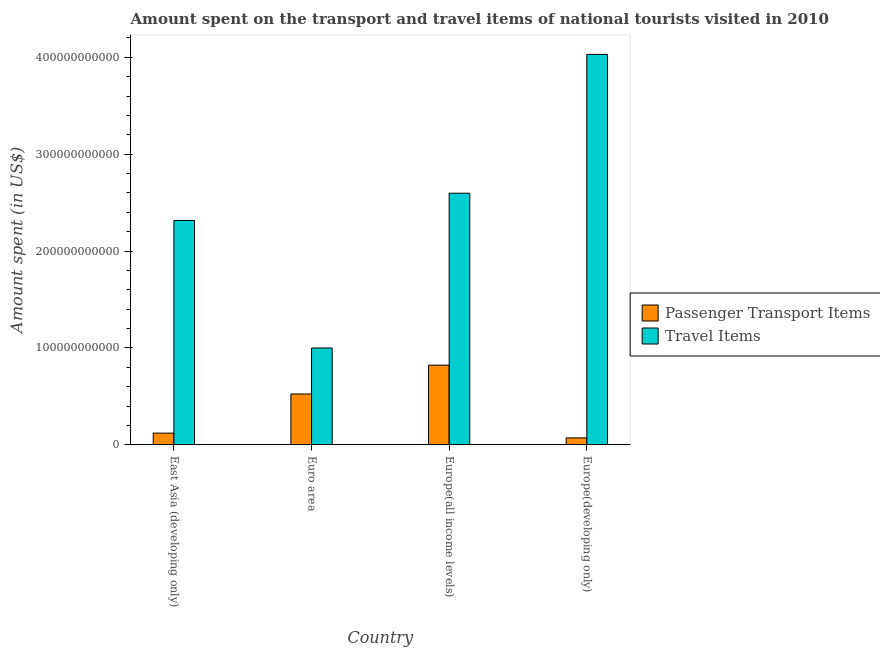How many groups of bars are there?
Make the answer very short. 4. How many bars are there on the 2nd tick from the left?
Ensure brevity in your answer.  2. How many bars are there on the 1st tick from the right?
Make the answer very short. 2. What is the label of the 3rd group of bars from the left?
Your response must be concise. Europe(all income levels). What is the amount spent on passenger transport items in Europe(developing only)?
Give a very brief answer. 7.14e+09. Across all countries, what is the maximum amount spent on passenger transport items?
Ensure brevity in your answer.  8.22e+1. Across all countries, what is the minimum amount spent in travel items?
Give a very brief answer. 9.99e+1. In which country was the amount spent in travel items maximum?
Give a very brief answer. Europe(developing only). In which country was the amount spent on passenger transport items minimum?
Provide a succinct answer. Europe(developing only). What is the total amount spent in travel items in the graph?
Your response must be concise. 9.94e+11. What is the difference between the amount spent in travel items in Europe(all income levels) and that in Europe(developing only)?
Provide a succinct answer. -1.43e+11. What is the difference between the amount spent in travel items in Euro area and the amount spent on passenger transport items in Europe(all income levels)?
Offer a very short reply. 1.77e+1. What is the average amount spent on passenger transport items per country?
Offer a very short reply. 3.85e+1. What is the difference between the amount spent on passenger transport items and amount spent in travel items in East Asia (developing only)?
Keep it short and to the point. -2.20e+11. What is the ratio of the amount spent in travel items in Europe(all income levels) to that in Europe(developing only)?
Your answer should be very brief. 0.64. Is the difference between the amount spent on passenger transport items in East Asia (developing only) and Europe(developing only) greater than the difference between the amount spent in travel items in East Asia (developing only) and Europe(developing only)?
Your response must be concise. Yes. What is the difference between the highest and the second highest amount spent in travel items?
Offer a very short reply. 1.43e+11. What is the difference between the highest and the lowest amount spent in travel items?
Make the answer very short. 3.03e+11. What does the 1st bar from the left in Europe(all income levels) represents?
Provide a short and direct response. Passenger Transport Items. What does the 1st bar from the right in Europe(developing only) represents?
Ensure brevity in your answer.  Travel Items. How many bars are there?
Offer a very short reply. 8. Are all the bars in the graph horizontal?
Keep it short and to the point. No. How many countries are there in the graph?
Your answer should be very brief. 4. What is the difference between two consecutive major ticks on the Y-axis?
Offer a terse response. 1.00e+11. Are the values on the major ticks of Y-axis written in scientific E-notation?
Ensure brevity in your answer.  No. Does the graph contain any zero values?
Give a very brief answer. No. How many legend labels are there?
Provide a succinct answer. 2. How are the legend labels stacked?
Offer a very short reply. Vertical. What is the title of the graph?
Ensure brevity in your answer.  Amount spent on the transport and travel items of national tourists visited in 2010. What is the label or title of the Y-axis?
Your response must be concise. Amount spent (in US$). What is the Amount spent (in US$) of Passenger Transport Items in East Asia (developing only)?
Keep it short and to the point. 1.20e+1. What is the Amount spent (in US$) of Travel Items in East Asia (developing only)?
Your response must be concise. 2.32e+11. What is the Amount spent (in US$) in Passenger Transport Items in Euro area?
Your answer should be compact. 5.25e+1. What is the Amount spent (in US$) in Travel Items in Euro area?
Your answer should be very brief. 9.99e+1. What is the Amount spent (in US$) in Passenger Transport Items in Europe(all income levels)?
Your response must be concise. 8.22e+1. What is the Amount spent (in US$) of Travel Items in Europe(all income levels)?
Provide a short and direct response. 2.60e+11. What is the Amount spent (in US$) in Passenger Transport Items in Europe(developing only)?
Ensure brevity in your answer.  7.14e+09. What is the Amount spent (in US$) of Travel Items in Europe(developing only)?
Offer a very short reply. 4.03e+11. Across all countries, what is the maximum Amount spent (in US$) in Passenger Transport Items?
Offer a terse response. 8.22e+1. Across all countries, what is the maximum Amount spent (in US$) in Travel Items?
Make the answer very short. 4.03e+11. Across all countries, what is the minimum Amount spent (in US$) of Passenger Transport Items?
Offer a very short reply. 7.14e+09. Across all countries, what is the minimum Amount spent (in US$) in Travel Items?
Keep it short and to the point. 9.99e+1. What is the total Amount spent (in US$) in Passenger Transport Items in the graph?
Your answer should be very brief. 1.54e+11. What is the total Amount spent (in US$) of Travel Items in the graph?
Your response must be concise. 9.94e+11. What is the difference between the Amount spent (in US$) in Passenger Transport Items in East Asia (developing only) and that in Euro area?
Keep it short and to the point. -4.04e+1. What is the difference between the Amount spent (in US$) of Travel Items in East Asia (developing only) and that in Euro area?
Offer a very short reply. 1.32e+11. What is the difference between the Amount spent (in US$) of Passenger Transport Items in East Asia (developing only) and that in Europe(all income levels)?
Provide a short and direct response. -7.02e+1. What is the difference between the Amount spent (in US$) of Travel Items in East Asia (developing only) and that in Europe(all income levels)?
Ensure brevity in your answer.  -2.81e+1. What is the difference between the Amount spent (in US$) in Passenger Transport Items in East Asia (developing only) and that in Europe(developing only)?
Give a very brief answer. 4.90e+09. What is the difference between the Amount spent (in US$) in Travel Items in East Asia (developing only) and that in Europe(developing only)?
Your answer should be very brief. -1.71e+11. What is the difference between the Amount spent (in US$) of Passenger Transport Items in Euro area and that in Europe(all income levels)?
Your answer should be very brief. -2.98e+1. What is the difference between the Amount spent (in US$) in Travel Items in Euro area and that in Europe(all income levels)?
Your answer should be compact. -1.60e+11. What is the difference between the Amount spent (in US$) of Passenger Transport Items in Euro area and that in Europe(developing only)?
Offer a very short reply. 4.53e+1. What is the difference between the Amount spent (in US$) of Travel Items in Euro area and that in Europe(developing only)?
Your answer should be compact. -3.03e+11. What is the difference between the Amount spent (in US$) in Passenger Transport Items in Europe(all income levels) and that in Europe(developing only)?
Your answer should be very brief. 7.51e+1. What is the difference between the Amount spent (in US$) in Travel Items in Europe(all income levels) and that in Europe(developing only)?
Ensure brevity in your answer.  -1.43e+11. What is the difference between the Amount spent (in US$) of Passenger Transport Items in East Asia (developing only) and the Amount spent (in US$) of Travel Items in Euro area?
Ensure brevity in your answer.  -8.79e+1. What is the difference between the Amount spent (in US$) of Passenger Transport Items in East Asia (developing only) and the Amount spent (in US$) of Travel Items in Europe(all income levels)?
Your answer should be compact. -2.48e+11. What is the difference between the Amount spent (in US$) of Passenger Transport Items in East Asia (developing only) and the Amount spent (in US$) of Travel Items in Europe(developing only)?
Your answer should be very brief. -3.91e+11. What is the difference between the Amount spent (in US$) in Passenger Transport Items in Euro area and the Amount spent (in US$) in Travel Items in Europe(all income levels)?
Offer a very short reply. -2.07e+11. What is the difference between the Amount spent (in US$) of Passenger Transport Items in Euro area and the Amount spent (in US$) of Travel Items in Europe(developing only)?
Provide a succinct answer. -3.51e+11. What is the difference between the Amount spent (in US$) of Passenger Transport Items in Europe(all income levels) and the Amount spent (in US$) of Travel Items in Europe(developing only)?
Offer a terse response. -3.21e+11. What is the average Amount spent (in US$) in Passenger Transport Items per country?
Ensure brevity in your answer.  3.85e+1. What is the average Amount spent (in US$) in Travel Items per country?
Keep it short and to the point. 2.49e+11. What is the difference between the Amount spent (in US$) in Passenger Transport Items and Amount spent (in US$) in Travel Items in East Asia (developing only)?
Ensure brevity in your answer.  -2.20e+11. What is the difference between the Amount spent (in US$) of Passenger Transport Items and Amount spent (in US$) of Travel Items in Euro area?
Your answer should be compact. -4.75e+1. What is the difference between the Amount spent (in US$) of Passenger Transport Items and Amount spent (in US$) of Travel Items in Europe(all income levels)?
Make the answer very short. -1.77e+11. What is the difference between the Amount spent (in US$) in Passenger Transport Items and Amount spent (in US$) in Travel Items in Europe(developing only)?
Offer a very short reply. -3.96e+11. What is the ratio of the Amount spent (in US$) of Passenger Transport Items in East Asia (developing only) to that in Euro area?
Offer a terse response. 0.23. What is the ratio of the Amount spent (in US$) in Travel Items in East Asia (developing only) to that in Euro area?
Your response must be concise. 2.32. What is the ratio of the Amount spent (in US$) in Passenger Transport Items in East Asia (developing only) to that in Europe(all income levels)?
Give a very brief answer. 0.15. What is the ratio of the Amount spent (in US$) in Travel Items in East Asia (developing only) to that in Europe(all income levels)?
Your answer should be very brief. 0.89. What is the ratio of the Amount spent (in US$) in Passenger Transport Items in East Asia (developing only) to that in Europe(developing only)?
Offer a terse response. 1.69. What is the ratio of the Amount spent (in US$) of Travel Items in East Asia (developing only) to that in Europe(developing only)?
Make the answer very short. 0.57. What is the ratio of the Amount spent (in US$) in Passenger Transport Items in Euro area to that in Europe(all income levels)?
Provide a succinct answer. 0.64. What is the ratio of the Amount spent (in US$) in Travel Items in Euro area to that in Europe(all income levels)?
Your response must be concise. 0.38. What is the ratio of the Amount spent (in US$) in Passenger Transport Items in Euro area to that in Europe(developing only)?
Your answer should be compact. 7.35. What is the ratio of the Amount spent (in US$) in Travel Items in Euro area to that in Europe(developing only)?
Offer a very short reply. 0.25. What is the ratio of the Amount spent (in US$) of Passenger Transport Items in Europe(all income levels) to that in Europe(developing only)?
Offer a very short reply. 11.52. What is the ratio of the Amount spent (in US$) of Travel Items in Europe(all income levels) to that in Europe(developing only)?
Offer a terse response. 0.64. What is the difference between the highest and the second highest Amount spent (in US$) of Passenger Transport Items?
Give a very brief answer. 2.98e+1. What is the difference between the highest and the second highest Amount spent (in US$) of Travel Items?
Provide a succinct answer. 1.43e+11. What is the difference between the highest and the lowest Amount spent (in US$) of Passenger Transport Items?
Give a very brief answer. 7.51e+1. What is the difference between the highest and the lowest Amount spent (in US$) of Travel Items?
Keep it short and to the point. 3.03e+11. 